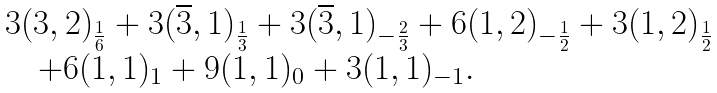<formula> <loc_0><loc_0><loc_500><loc_500>\begin{array} { l } 3 ( 3 , 2 ) _ { \frac { 1 } { 6 } } + 3 ( \overline { 3 } , 1 ) _ { \frac { 1 } { 3 } } + 3 ( \overline { 3 } , 1 ) _ { - \frac { 2 } { 3 } } + 6 ( 1 , 2 ) _ { - \frac { 1 } { 2 } } + 3 ( 1 , 2 ) _ { \frac { 1 } { 2 } } \\ \quad + 6 ( 1 , 1 ) _ { 1 } + 9 ( 1 , 1 ) _ { 0 } + 3 ( 1 , 1 ) _ { - 1 } . \end{array}</formula> 